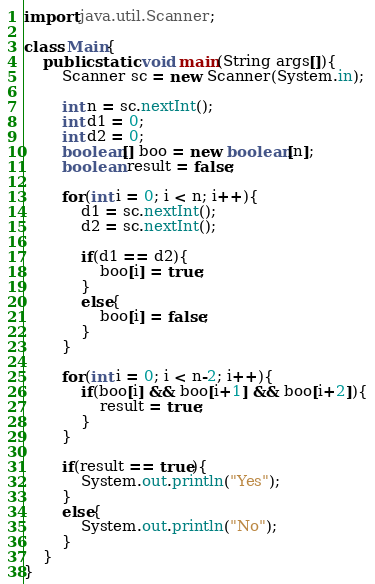Convert code to text. <code><loc_0><loc_0><loc_500><loc_500><_Java_>import java.util.Scanner;

class Main{
    public static void main(String args[]){
        Scanner sc = new Scanner(System.in);

        int n = sc.nextInt();
        int d1 = 0;
        int d2 = 0;
        boolean[] boo = new boolean[n];
        boolean result = false;

        for(int i = 0; i < n; i++){
            d1 = sc.nextInt();
            d2 = sc.nextInt();

            if(d1 == d2){
                boo[i] = true;
            }
            else{
                boo[i] = false;
            }
        }

        for(int i = 0; i < n-2; i++){
            if(boo[i] && boo[i+1] && boo[i+2]){
                result = true;
            }
        }

        if(result == true){
            System.out.println("Yes");
        }
        else{
            System.out.println("No");
        }
    }    
}</code> 